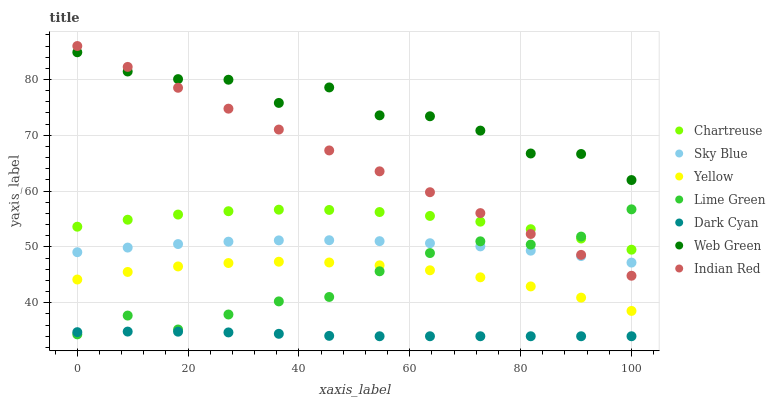Does Dark Cyan have the minimum area under the curve?
Answer yes or no. Yes. Does Web Green have the maximum area under the curve?
Answer yes or no. Yes. Does Chartreuse have the minimum area under the curve?
Answer yes or no. No. Does Chartreuse have the maximum area under the curve?
Answer yes or no. No. Is Indian Red the smoothest?
Answer yes or no. Yes. Is Web Green the roughest?
Answer yes or no. Yes. Is Chartreuse the smoothest?
Answer yes or no. No. Is Chartreuse the roughest?
Answer yes or no. No. Does Dark Cyan have the lowest value?
Answer yes or no. Yes. Does Chartreuse have the lowest value?
Answer yes or no. No. Does Indian Red have the highest value?
Answer yes or no. Yes. Does Chartreuse have the highest value?
Answer yes or no. No. Is Dark Cyan less than Yellow?
Answer yes or no. Yes. Is Yellow greater than Dark Cyan?
Answer yes or no. Yes. Does Sky Blue intersect Lime Green?
Answer yes or no. Yes. Is Sky Blue less than Lime Green?
Answer yes or no. No. Is Sky Blue greater than Lime Green?
Answer yes or no. No. Does Dark Cyan intersect Yellow?
Answer yes or no. No. 